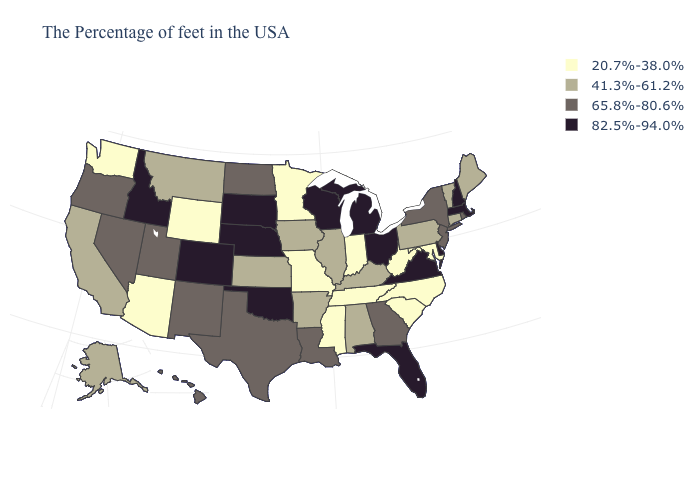Name the states that have a value in the range 41.3%-61.2%?
Concise answer only. Maine, Vermont, Connecticut, Pennsylvania, Kentucky, Alabama, Illinois, Arkansas, Iowa, Kansas, Montana, California, Alaska. Which states have the lowest value in the MidWest?
Give a very brief answer. Indiana, Missouri, Minnesota. What is the value of Hawaii?
Keep it brief. 65.8%-80.6%. What is the highest value in states that border Tennessee?
Write a very short answer. 82.5%-94.0%. What is the value of Rhode Island?
Give a very brief answer. 65.8%-80.6%. Does the first symbol in the legend represent the smallest category?
Give a very brief answer. Yes. What is the value of Georgia?
Be succinct. 65.8%-80.6%. Does the first symbol in the legend represent the smallest category?
Answer briefly. Yes. What is the highest value in the South ?
Quick response, please. 82.5%-94.0%. Which states hav the highest value in the South?
Quick response, please. Delaware, Virginia, Florida, Oklahoma. Name the states that have a value in the range 41.3%-61.2%?
Concise answer only. Maine, Vermont, Connecticut, Pennsylvania, Kentucky, Alabama, Illinois, Arkansas, Iowa, Kansas, Montana, California, Alaska. Name the states that have a value in the range 41.3%-61.2%?
Write a very short answer. Maine, Vermont, Connecticut, Pennsylvania, Kentucky, Alabama, Illinois, Arkansas, Iowa, Kansas, Montana, California, Alaska. What is the lowest value in the South?
Keep it brief. 20.7%-38.0%. What is the value of Florida?
Give a very brief answer. 82.5%-94.0%. What is the highest value in states that border Tennessee?
Give a very brief answer. 82.5%-94.0%. 